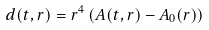<formula> <loc_0><loc_0><loc_500><loc_500>d ( t , r ) = r ^ { 4 } \left ( A ( t , r ) - A _ { 0 } ( r ) \right )</formula> 